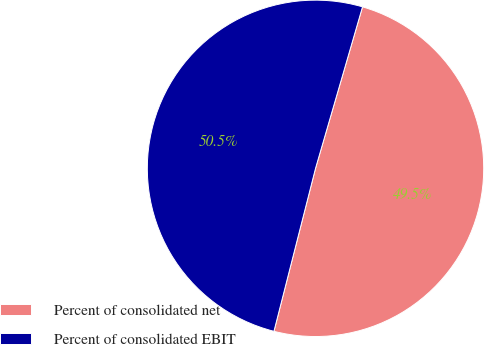Convert chart to OTSL. <chart><loc_0><loc_0><loc_500><loc_500><pie_chart><fcel>Percent of consolidated net<fcel>Percent of consolidated EBIT<nl><fcel>49.47%<fcel>50.53%<nl></chart> 